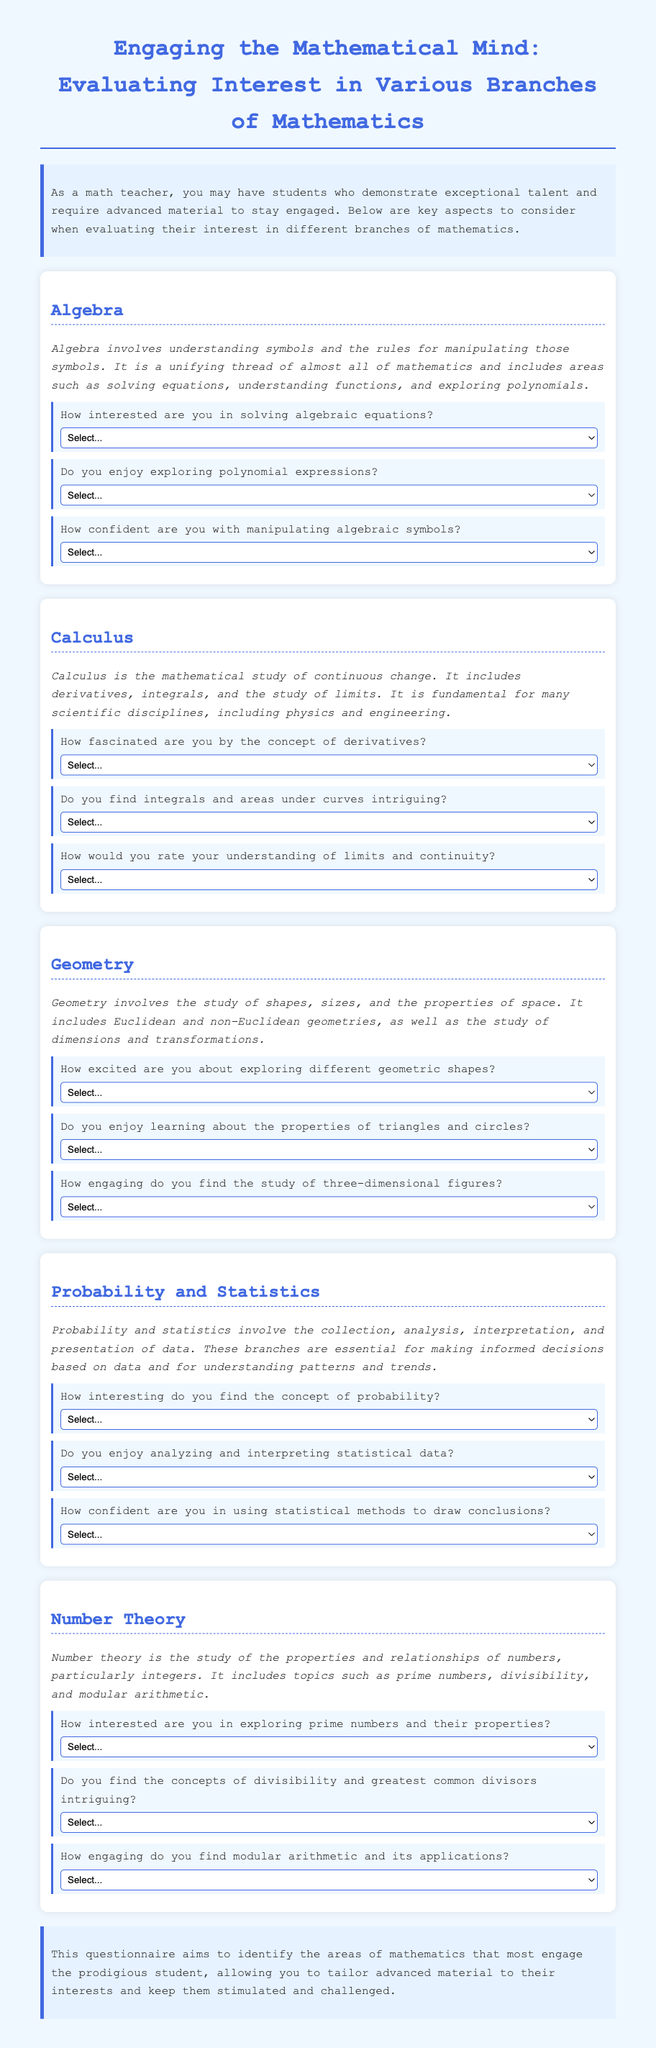What is the title of the document? The title is stated explicitly at the beginning of the document, and it describes the purpose of the questionnaire.
Answer: Engaging the Mathematical Mind: Evaluating Interest in Various Branches of Mathematics How many sections are in the document? The document is divided into multiple sections, each covering a specific branch of mathematics.
Answer: Five What is the focus of the Probability and Statistics section? The section description encapsulates the main topic and its relevance to data-related decision-making.
Answer: Collection, analysis, interpretation, and presentation of data How confident can a student feel about manipulating algebraic symbols? The document lists a scale for students to rate their confidence in algebraic skills, specifically for manipulating symbols.
Answer: Not confident to Extremely confident What is the highest rating available for interest in exploring prime numbers? The questionnaire provides a rating scale for interest levels with the highest option representing maximum interest.
Answer: Extremely interested In which section would you learn about limits and continuity? The document categorizes topics, with specific questions assigned to a certain mathematical discipline.
Answer: Calculus How excited can a student feel about exploring geometric shapes? The questionnaire uses a scale to evaluate a student's excitement about learning geometry.
Answer: Not excited to Extremely excited What are the three questions asked in the Geometry section? The document outlines specific questions for different branches of mathematics, with unique inquiries for each section.
Answer: How excited are you about exploring different geometric shapes? Do you enjoy learning about the properties of triangles and circles? How engaging do you find the study of three-dimensional figures? What concept does the Number Theory section primarily focus on? The document describes the main themes addressed in number theory along with its specific topics.
Answer: Properties and relationships of numbers, particularly integers 